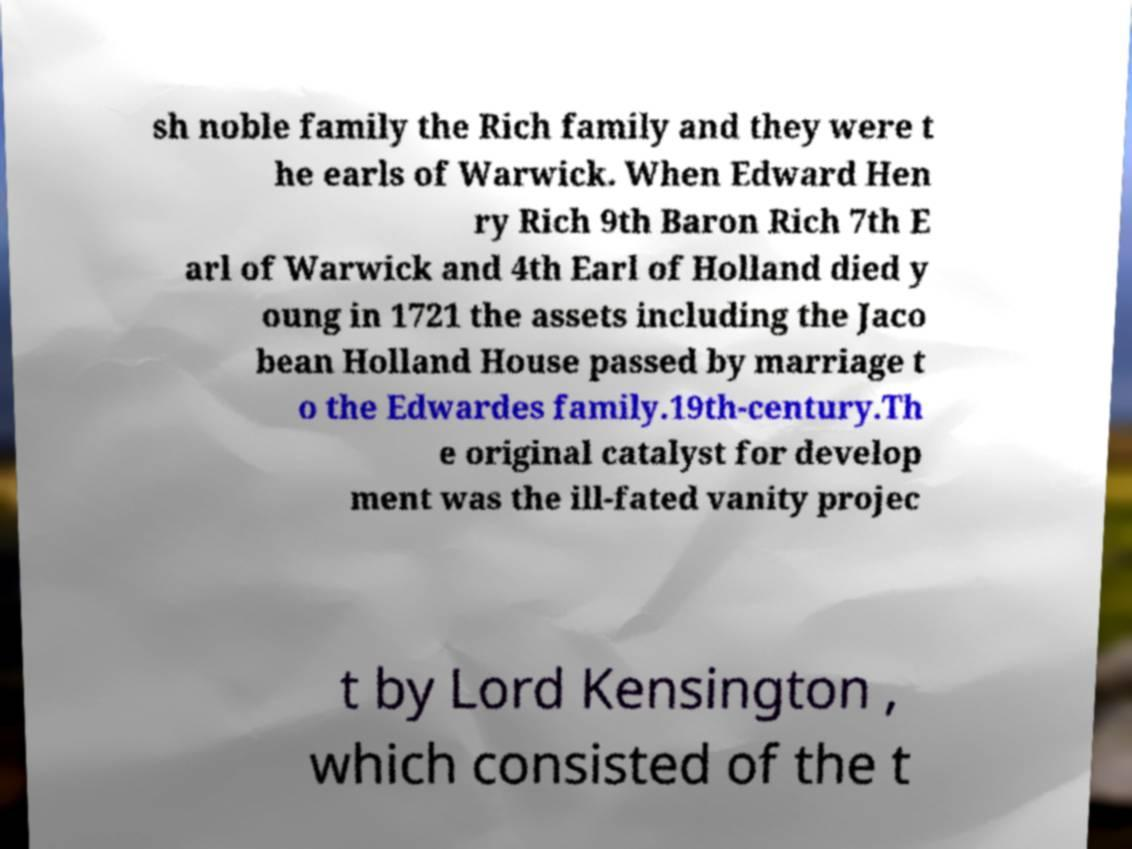Can you accurately transcribe the text from the provided image for me? sh noble family the Rich family and they were t he earls of Warwick. When Edward Hen ry Rich 9th Baron Rich 7th E arl of Warwick and 4th Earl of Holland died y oung in 1721 the assets including the Jaco bean Holland House passed by marriage t o the Edwardes family.19th-century.Th e original catalyst for develop ment was the ill-fated vanity projec t by Lord Kensington , which consisted of the t 